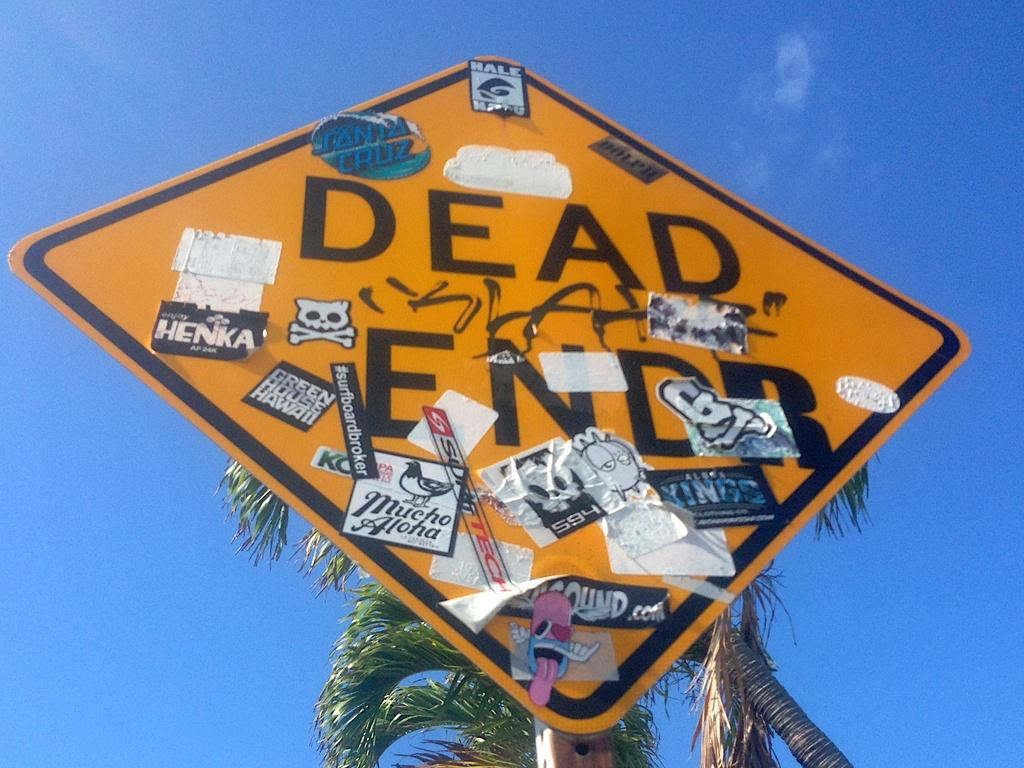<image>
Relay a brief, clear account of the picture shown. A "Dead End" sign is adorned with many stickers, including one that says Henka. 